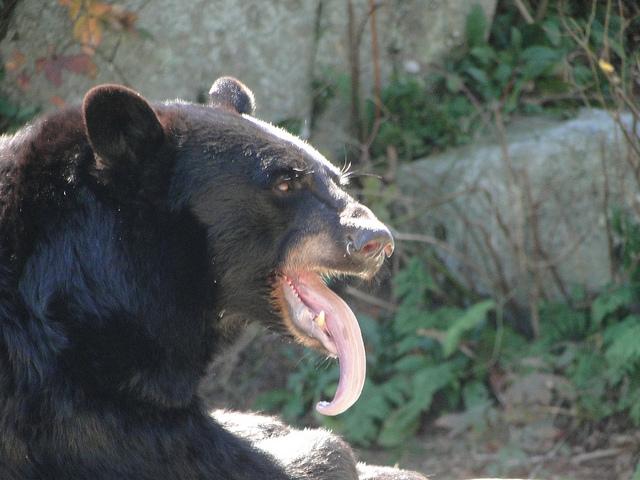Is the bear hungry?
Keep it brief. Yes. Where is the bear looking?
Keep it brief. Right. How many claws are seen?
Answer briefly. 0. What color bear?
Answer briefly. Black. Is this animal hunting for food?
Write a very short answer. No. Does the bear look hungry?
Quick response, please. Yes. Do you see a long tongue?
Short answer required. Yes. 